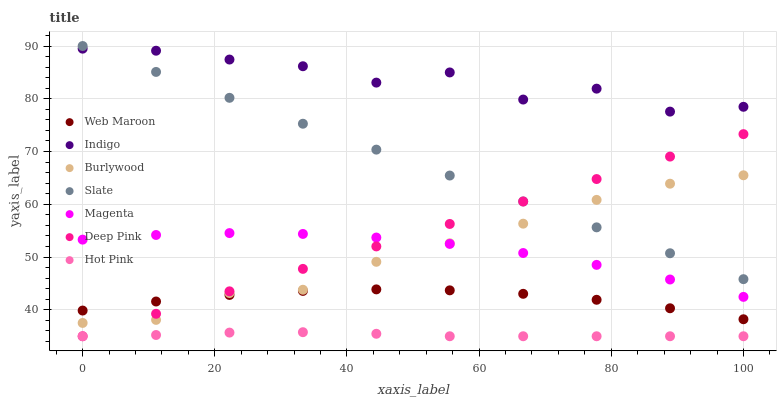Does Hot Pink have the minimum area under the curve?
Answer yes or no. Yes. Does Indigo have the maximum area under the curve?
Answer yes or no. Yes. Does Burlywood have the minimum area under the curve?
Answer yes or no. No. Does Burlywood have the maximum area under the curve?
Answer yes or no. No. Is Slate the smoothest?
Answer yes or no. Yes. Is Indigo the roughest?
Answer yes or no. Yes. Is Burlywood the smoothest?
Answer yes or no. No. Is Burlywood the roughest?
Answer yes or no. No. Does Deep Pink have the lowest value?
Answer yes or no. Yes. Does Burlywood have the lowest value?
Answer yes or no. No. Does Slate have the highest value?
Answer yes or no. Yes. Does Indigo have the highest value?
Answer yes or no. No. Is Burlywood less than Indigo?
Answer yes or no. Yes. Is Web Maroon greater than Hot Pink?
Answer yes or no. Yes. Does Burlywood intersect Magenta?
Answer yes or no. Yes. Is Burlywood less than Magenta?
Answer yes or no. No. Is Burlywood greater than Magenta?
Answer yes or no. No. Does Burlywood intersect Indigo?
Answer yes or no. No. 